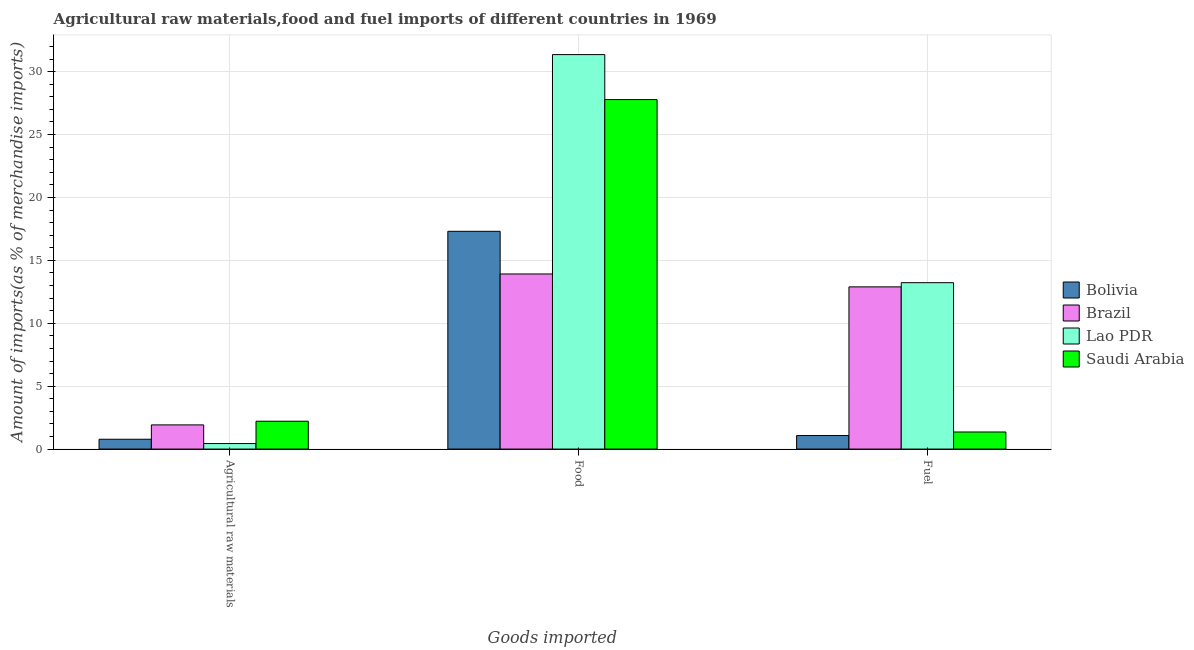How many groups of bars are there?
Provide a short and direct response. 3. How many bars are there on the 1st tick from the left?
Offer a very short reply. 4. What is the label of the 3rd group of bars from the left?
Your answer should be very brief. Fuel. What is the percentage of raw materials imports in Bolivia?
Ensure brevity in your answer.  0.78. Across all countries, what is the maximum percentage of fuel imports?
Ensure brevity in your answer.  13.23. Across all countries, what is the minimum percentage of fuel imports?
Your answer should be compact. 1.08. In which country was the percentage of fuel imports maximum?
Make the answer very short. Lao PDR. What is the total percentage of food imports in the graph?
Your answer should be very brief. 90.36. What is the difference between the percentage of food imports in Saudi Arabia and that in Lao PDR?
Provide a short and direct response. -3.57. What is the difference between the percentage of raw materials imports in Bolivia and the percentage of food imports in Saudi Arabia?
Offer a terse response. -27. What is the average percentage of raw materials imports per country?
Ensure brevity in your answer.  1.34. What is the difference between the percentage of food imports and percentage of fuel imports in Saudi Arabia?
Provide a succinct answer. 26.42. What is the ratio of the percentage of food imports in Saudi Arabia to that in Bolivia?
Your response must be concise. 1.6. Is the percentage of fuel imports in Lao PDR less than that in Bolivia?
Give a very brief answer. No. Is the difference between the percentage of fuel imports in Lao PDR and Brazil greater than the difference between the percentage of raw materials imports in Lao PDR and Brazil?
Offer a terse response. Yes. What is the difference between the highest and the second highest percentage of food imports?
Offer a very short reply. 3.57. What is the difference between the highest and the lowest percentage of food imports?
Ensure brevity in your answer.  17.44. In how many countries, is the percentage of fuel imports greater than the average percentage of fuel imports taken over all countries?
Offer a terse response. 2. What does the 3rd bar from the left in Fuel represents?
Offer a very short reply. Lao PDR. What does the 2nd bar from the right in Food represents?
Your answer should be very brief. Lao PDR. How many bars are there?
Your answer should be very brief. 12. Are all the bars in the graph horizontal?
Offer a terse response. No. How many countries are there in the graph?
Your answer should be very brief. 4. What is the difference between two consecutive major ticks on the Y-axis?
Give a very brief answer. 5. Are the values on the major ticks of Y-axis written in scientific E-notation?
Provide a succinct answer. No. Does the graph contain any zero values?
Keep it short and to the point. No. How many legend labels are there?
Your answer should be compact. 4. How are the legend labels stacked?
Your response must be concise. Vertical. What is the title of the graph?
Offer a terse response. Agricultural raw materials,food and fuel imports of different countries in 1969. Does "Costa Rica" appear as one of the legend labels in the graph?
Keep it short and to the point. No. What is the label or title of the X-axis?
Offer a terse response. Goods imported. What is the label or title of the Y-axis?
Your answer should be compact. Amount of imports(as % of merchandise imports). What is the Amount of imports(as % of merchandise imports) in Bolivia in Agricultural raw materials?
Your answer should be very brief. 0.78. What is the Amount of imports(as % of merchandise imports) in Brazil in Agricultural raw materials?
Ensure brevity in your answer.  1.92. What is the Amount of imports(as % of merchandise imports) in Lao PDR in Agricultural raw materials?
Offer a very short reply. 0.44. What is the Amount of imports(as % of merchandise imports) in Saudi Arabia in Agricultural raw materials?
Make the answer very short. 2.21. What is the Amount of imports(as % of merchandise imports) in Bolivia in Food?
Offer a very short reply. 17.31. What is the Amount of imports(as % of merchandise imports) of Brazil in Food?
Provide a succinct answer. 13.92. What is the Amount of imports(as % of merchandise imports) of Lao PDR in Food?
Keep it short and to the point. 31.35. What is the Amount of imports(as % of merchandise imports) of Saudi Arabia in Food?
Your answer should be compact. 27.78. What is the Amount of imports(as % of merchandise imports) in Bolivia in Fuel?
Give a very brief answer. 1.08. What is the Amount of imports(as % of merchandise imports) in Brazil in Fuel?
Give a very brief answer. 12.89. What is the Amount of imports(as % of merchandise imports) in Lao PDR in Fuel?
Provide a short and direct response. 13.23. What is the Amount of imports(as % of merchandise imports) in Saudi Arabia in Fuel?
Make the answer very short. 1.36. Across all Goods imported, what is the maximum Amount of imports(as % of merchandise imports) of Bolivia?
Offer a very short reply. 17.31. Across all Goods imported, what is the maximum Amount of imports(as % of merchandise imports) in Brazil?
Keep it short and to the point. 13.92. Across all Goods imported, what is the maximum Amount of imports(as % of merchandise imports) in Lao PDR?
Offer a terse response. 31.35. Across all Goods imported, what is the maximum Amount of imports(as % of merchandise imports) in Saudi Arabia?
Give a very brief answer. 27.78. Across all Goods imported, what is the minimum Amount of imports(as % of merchandise imports) of Bolivia?
Offer a very short reply. 0.78. Across all Goods imported, what is the minimum Amount of imports(as % of merchandise imports) in Brazil?
Make the answer very short. 1.92. Across all Goods imported, what is the minimum Amount of imports(as % of merchandise imports) of Lao PDR?
Keep it short and to the point. 0.44. Across all Goods imported, what is the minimum Amount of imports(as % of merchandise imports) in Saudi Arabia?
Your response must be concise. 1.36. What is the total Amount of imports(as % of merchandise imports) of Bolivia in the graph?
Your answer should be compact. 19.17. What is the total Amount of imports(as % of merchandise imports) in Brazil in the graph?
Your answer should be compact. 28.73. What is the total Amount of imports(as % of merchandise imports) of Lao PDR in the graph?
Give a very brief answer. 45.02. What is the total Amount of imports(as % of merchandise imports) of Saudi Arabia in the graph?
Provide a succinct answer. 31.35. What is the difference between the Amount of imports(as % of merchandise imports) in Bolivia in Agricultural raw materials and that in Food?
Give a very brief answer. -16.53. What is the difference between the Amount of imports(as % of merchandise imports) in Brazil in Agricultural raw materials and that in Food?
Give a very brief answer. -12. What is the difference between the Amount of imports(as % of merchandise imports) in Lao PDR in Agricultural raw materials and that in Food?
Ensure brevity in your answer.  -30.92. What is the difference between the Amount of imports(as % of merchandise imports) in Saudi Arabia in Agricultural raw materials and that in Food?
Your response must be concise. -25.57. What is the difference between the Amount of imports(as % of merchandise imports) of Bolivia in Agricultural raw materials and that in Fuel?
Your response must be concise. -0.3. What is the difference between the Amount of imports(as % of merchandise imports) of Brazil in Agricultural raw materials and that in Fuel?
Provide a succinct answer. -10.97. What is the difference between the Amount of imports(as % of merchandise imports) of Lao PDR in Agricultural raw materials and that in Fuel?
Offer a terse response. -12.79. What is the difference between the Amount of imports(as % of merchandise imports) of Saudi Arabia in Agricultural raw materials and that in Fuel?
Give a very brief answer. 0.86. What is the difference between the Amount of imports(as % of merchandise imports) in Bolivia in Food and that in Fuel?
Give a very brief answer. 16.23. What is the difference between the Amount of imports(as % of merchandise imports) in Brazil in Food and that in Fuel?
Provide a succinct answer. 1.02. What is the difference between the Amount of imports(as % of merchandise imports) of Lao PDR in Food and that in Fuel?
Your answer should be compact. 18.13. What is the difference between the Amount of imports(as % of merchandise imports) in Saudi Arabia in Food and that in Fuel?
Make the answer very short. 26.42. What is the difference between the Amount of imports(as % of merchandise imports) of Bolivia in Agricultural raw materials and the Amount of imports(as % of merchandise imports) of Brazil in Food?
Provide a short and direct response. -13.14. What is the difference between the Amount of imports(as % of merchandise imports) of Bolivia in Agricultural raw materials and the Amount of imports(as % of merchandise imports) of Lao PDR in Food?
Make the answer very short. -30.57. What is the difference between the Amount of imports(as % of merchandise imports) of Bolivia in Agricultural raw materials and the Amount of imports(as % of merchandise imports) of Saudi Arabia in Food?
Give a very brief answer. -27. What is the difference between the Amount of imports(as % of merchandise imports) in Brazil in Agricultural raw materials and the Amount of imports(as % of merchandise imports) in Lao PDR in Food?
Make the answer very short. -29.43. What is the difference between the Amount of imports(as % of merchandise imports) in Brazil in Agricultural raw materials and the Amount of imports(as % of merchandise imports) in Saudi Arabia in Food?
Give a very brief answer. -25.86. What is the difference between the Amount of imports(as % of merchandise imports) of Lao PDR in Agricultural raw materials and the Amount of imports(as % of merchandise imports) of Saudi Arabia in Food?
Your response must be concise. -27.34. What is the difference between the Amount of imports(as % of merchandise imports) of Bolivia in Agricultural raw materials and the Amount of imports(as % of merchandise imports) of Brazil in Fuel?
Provide a succinct answer. -12.11. What is the difference between the Amount of imports(as % of merchandise imports) of Bolivia in Agricultural raw materials and the Amount of imports(as % of merchandise imports) of Lao PDR in Fuel?
Ensure brevity in your answer.  -12.45. What is the difference between the Amount of imports(as % of merchandise imports) of Bolivia in Agricultural raw materials and the Amount of imports(as % of merchandise imports) of Saudi Arabia in Fuel?
Give a very brief answer. -0.58. What is the difference between the Amount of imports(as % of merchandise imports) of Brazil in Agricultural raw materials and the Amount of imports(as % of merchandise imports) of Lao PDR in Fuel?
Your answer should be very brief. -11.3. What is the difference between the Amount of imports(as % of merchandise imports) in Brazil in Agricultural raw materials and the Amount of imports(as % of merchandise imports) in Saudi Arabia in Fuel?
Your answer should be very brief. 0.56. What is the difference between the Amount of imports(as % of merchandise imports) of Lao PDR in Agricultural raw materials and the Amount of imports(as % of merchandise imports) of Saudi Arabia in Fuel?
Provide a short and direct response. -0.92. What is the difference between the Amount of imports(as % of merchandise imports) in Bolivia in Food and the Amount of imports(as % of merchandise imports) in Brazil in Fuel?
Your answer should be compact. 4.42. What is the difference between the Amount of imports(as % of merchandise imports) in Bolivia in Food and the Amount of imports(as % of merchandise imports) in Lao PDR in Fuel?
Offer a very short reply. 4.08. What is the difference between the Amount of imports(as % of merchandise imports) in Bolivia in Food and the Amount of imports(as % of merchandise imports) in Saudi Arabia in Fuel?
Your response must be concise. 15.95. What is the difference between the Amount of imports(as % of merchandise imports) of Brazil in Food and the Amount of imports(as % of merchandise imports) of Lao PDR in Fuel?
Keep it short and to the point. 0.69. What is the difference between the Amount of imports(as % of merchandise imports) of Brazil in Food and the Amount of imports(as % of merchandise imports) of Saudi Arabia in Fuel?
Provide a succinct answer. 12.56. What is the difference between the Amount of imports(as % of merchandise imports) of Lao PDR in Food and the Amount of imports(as % of merchandise imports) of Saudi Arabia in Fuel?
Provide a succinct answer. 30. What is the average Amount of imports(as % of merchandise imports) of Bolivia per Goods imported?
Ensure brevity in your answer.  6.39. What is the average Amount of imports(as % of merchandise imports) of Brazil per Goods imported?
Keep it short and to the point. 9.58. What is the average Amount of imports(as % of merchandise imports) in Lao PDR per Goods imported?
Offer a very short reply. 15.01. What is the average Amount of imports(as % of merchandise imports) in Saudi Arabia per Goods imported?
Offer a terse response. 10.45. What is the difference between the Amount of imports(as % of merchandise imports) in Bolivia and Amount of imports(as % of merchandise imports) in Brazil in Agricultural raw materials?
Give a very brief answer. -1.14. What is the difference between the Amount of imports(as % of merchandise imports) in Bolivia and Amount of imports(as % of merchandise imports) in Lao PDR in Agricultural raw materials?
Provide a short and direct response. 0.34. What is the difference between the Amount of imports(as % of merchandise imports) in Bolivia and Amount of imports(as % of merchandise imports) in Saudi Arabia in Agricultural raw materials?
Provide a succinct answer. -1.43. What is the difference between the Amount of imports(as % of merchandise imports) of Brazil and Amount of imports(as % of merchandise imports) of Lao PDR in Agricultural raw materials?
Your answer should be compact. 1.48. What is the difference between the Amount of imports(as % of merchandise imports) in Brazil and Amount of imports(as % of merchandise imports) in Saudi Arabia in Agricultural raw materials?
Provide a short and direct response. -0.29. What is the difference between the Amount of imports(as % of merchandise imports) of Lao PDR and Amount of imports(as % of merchandise imports) of Saudi Arabia in Agricultural raw materials?
Keep it short and to the point. -1.78. What is the difference between the Amount of imports(as % of merchandise imports) of Bolivia and Amount of imports(as % of merchandise imports) of Brazil in Food?
Ensure brevity in your answer.  3.39. What is the difference between the Amount of imports(as % of merchandise imports) in Bolivia and Amount of imports(as % of merchandise imports) in Lao PDR in Food?
Offer a very short reply. -14.05. What is the difference between the Amount of imports(as % of merchandise imports) in Bolivia and Amount of imports(as % of merchandise imports) in Saudi Arabia in Food?
Your response must be concise. -10.47. What is the difference between the Amount of imports(as % of merchandise imports) of Brazil and Amount of imports(as % of merchandise imports) of Lao PDR in Food?
Make the answer very short. -17.44. What is the difference between the Amount of imports(as % of merchandise imports) of Brazil and Amount of imports(as % of merchandise imports) of Saudi Arabia in Food?
Offer a terse response. -13.86. What is the difference between the Amount of imports(as % of merchandise imports) of Lao PDR and Amount of imports(as % of merchandise imports) of Saudi Arabia in Food?
Ensure brevity in your answer.  3.57. What is the difference between the Amount of imports(as % of merchandise imports) of Bolivia and Amount of imports(as % of merchandise imports) of Brazil in Fuel?
Ensure brevity in your answer.  -11.82. What is the difference between the Amount of imports(as % of merchandise imports) of Bolivia and Amount of imports(as % of merchandise imports) of Lao PDR in Fuel?
Your answer should be compact. -12.15. What is the difference between the Amount of imports(as % of merchandise imports) of Bolivia and Amount of imports(as % of merchandise imports) of Saudi Arabia in Fuel?
Your answer should be compact. -0.28. What is the difference between the Amount of imports(as % of merchandise imports) in Brazil and Amount of imports(as % of merchandise imports) in Lao PDR in Fuel?
Keep it short and to the point. -0.33. What is the difference between the Amount of imports(as % of merchandise imports) of Brazil and Amount of imports(as % of merchandise imports) of Saudi Arabia in Fuel?
Your answer should be compact. 11.54. What is the difference between the Amount of imports(as % of merchandise imports) of Lao PDR and Amount of imports(as % of merchandise imports) of Saudi Arabia in Fuel?
Your answer should be compact. 11.87. What is the ratio of the Amount of imports(as % of merchandise imports) of Bolivia in Agricultural raw materials to that in Food?
Offer a very short reply. 0.05. What is the ratio of the Amount of imports(as % of merchandise imports) of Brazil in Agricultural raw materials to that in Food?
Keep it short and to the point. 0.14. What is the ratio of the Amount of imports(as % of merchandise imports) of Lao PDR in Agricultural raw materials to that in Food?
Your answer should be very brief. 0.01. What is the ratio of the Amount of imports(as % of merchandise imports) in Saudi Arabia in Agricultural raw materials to that in Food?
Ensure brevity in your answer.  0.08. What is the ratio of the Amount of imports(as % of merchandise imports) in Bolivia in Agricultural raw materials to that in Fuel?
Offer a terse response. 0.73. What is the ratio of the Amount of imports(as % of merchandise imports) in Brazil in Agricultural raw materials to that in Fuel?
Provide a succinct answer. 0.15. What is the ratio of the Amount of imports(as % of merchandise imports) in Lao PDR in Agricultural raw materials to that in Fuel?
Your answer should be very brief. 0.03. What is the ratio of the Amount of imports(as % of merchandise imports) of Saudi Arabia in Agricultural raw materials to that in Fuel?
Provide a short and direct response. 1.63. What is the ratio of the Amount of imports(as % of merchandise imports) in Bolivia in Food to that in Fuel?
Keep it short and to the point. 16.07. What is the ratio of the Amount of imports(as % of merchandise imports) of Brazil in Food to that in Fuel?
Your answer should be compact. 1.08. What is the ratio of the Amount of imports(as % of merchandise imports) of Lao PDR in Food to that in Fuel?
Your response must be concise. 2.37. What is the ratio of the Amount of imports(as % of merchandise imports) in Saudi Arabia in Food to that in Fuel?
Keep it short and to the point. 20.46. What is the difference between the highest and the second highest Amount of imports(as % of merchandise imports) of Bolivia?
Offer a terse response. 16.23. What is the difference between the highest and the second highest Amount of imports(as % of merchandise imports) in Brazil?
Ensure brevity in your answer.  1.02. What is the difference between the highest and the second highest Amount of imports(as % of merchandise imports) in Lao PDR?
Your answer should be compact. 18.13. What is the difference between the highest and the second highest Amount of imports(as % of merchandise imports) in Saudi Arabia?
Offer a very short reply. 25.57. What is the difference between the highest and the lowest Amount of imports(as % of merchandise imports) of Bolivia?
Ensure brevity in your answer.  16.53. What is the difference between the highest and the lowest Amount of imports(as % of merchandise imports) in Brazil?
Give a very brief answer. 12. What is the difference between the highest and the lowest Amount of imports(as % of merchandise imports) of Lao PDR?
Give a very brief answer. 30.92. What is the difference between the highest and the lowest Amount of imports(as % of merchandise imports) in Saudi Arabia?
Ensure brevity in your answer.  26.42. 